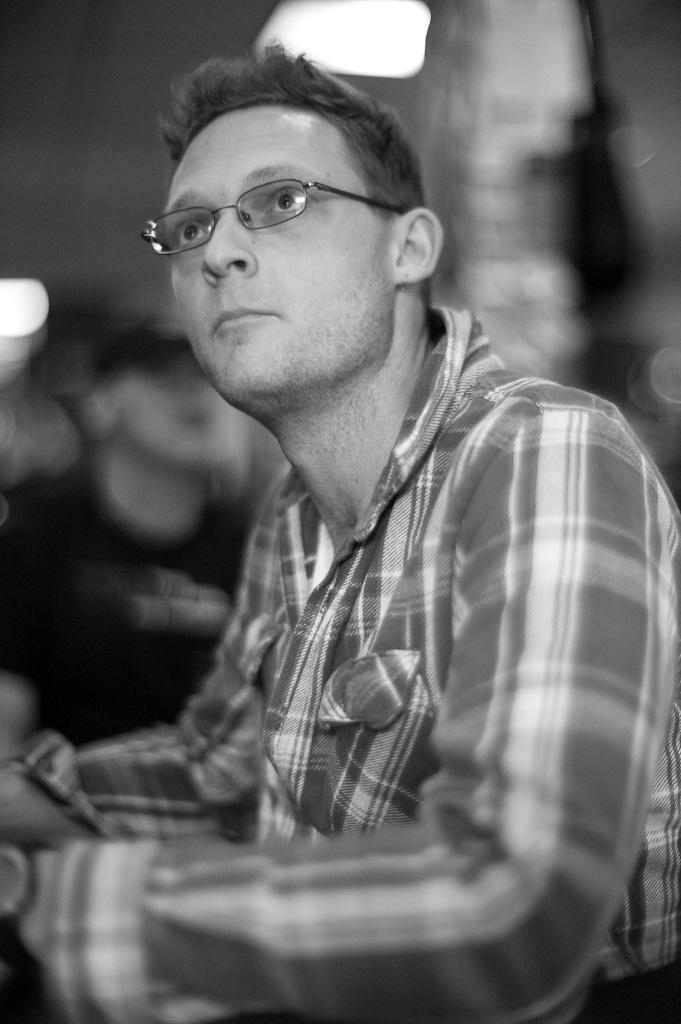Could you give a brief overview of what you see in this image? In this picture we can see a man in the front, he wore spectacles, there is a blurry background, it is a black and white image. 